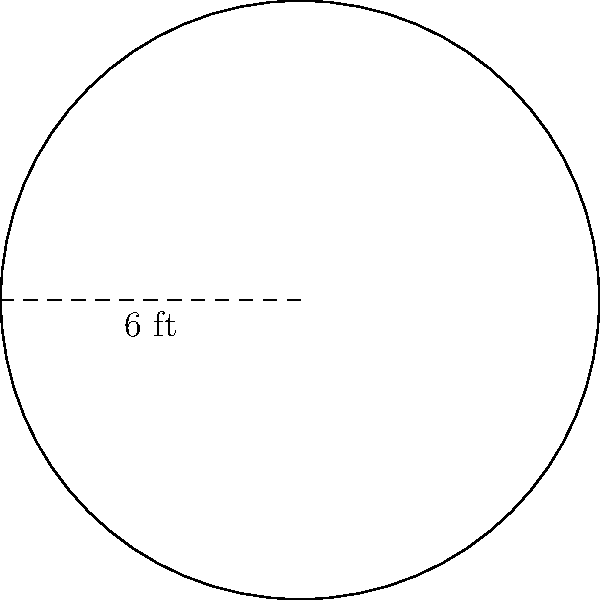In your cozy reading nook, you want to place a circular rug for story time with your grandchildren. If the rug has a radius of 6 feet, what is the area of the rug in square feet? Round your answer to the nearest whole number. To find the area of a circular rug, we need to use the formula for the area of a circle:

$$A = \pi r^2$$

Where:
$A$ = Area of the circle
$\pi$ = Pi (approximately 3.14159)
$r$ = Radius of the circle

Given:
Radius ($r$) = 6 feet

Let's calculate:

1) Substitute the values into the formula:
   $$A = \pi \cdot 6^2$$

2) Calculate the square of the radius:
   $$A = \pi \cdot 36$$

3) Multiply by $\pi$:
   $$A = 113.0973... \text{ sq ft}$$

4) Round to the nearest whole number:
   $$A \approx 113 \text{ sq ft}$$
Answer: 113 sq ft 